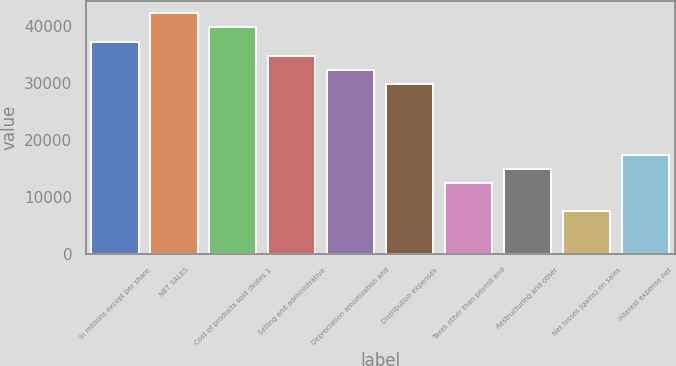<chart> <loc_0><loc_0><loc_500><loc_500><bar_chart><fcel>In millions except per share<fcel>NET SALES<fcel>Cost of products sold (Notes 1<fcel>Selling and administrative<fcel>Depreciation amortization and<fcel>Distribution expenses<fcel>Taxes other than payroll and<fcel>Restructuring and other<fcel>Net losses (gains) on sales<fcel>Interest expense net<nl><fcel>37242<fcel>42207.2<fcel>39724.6<fcel>34759.4<fcel>32276.8<fcel>29794.2<fcel>12416<fcel>14898.6<fcel>7450.8<fcel>17381.2<nl></chart> 